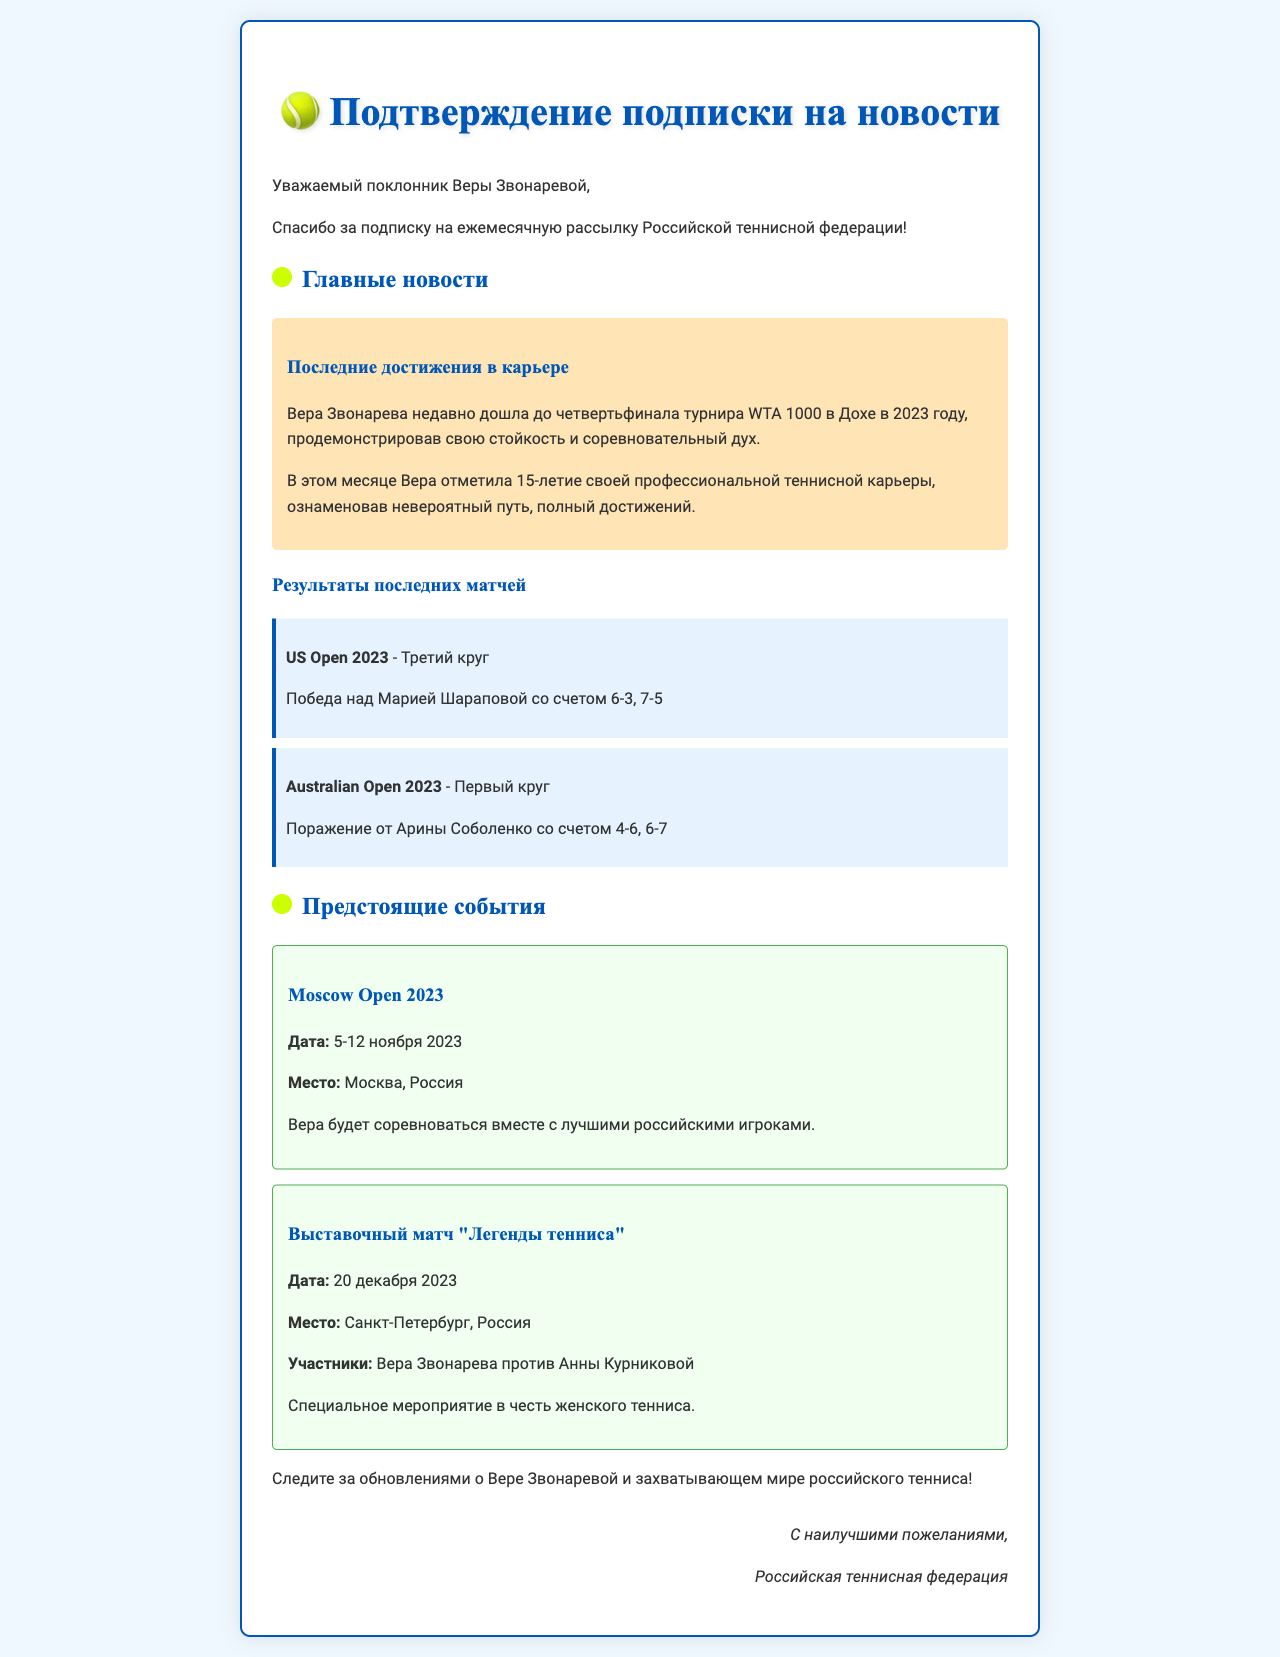what is the latest tournament achievement of Vera Zvonareva? Vera Zvonareva recently reached the quarter-finals of the WTA 1000 tournament in Doha in 2023.
Answer: quarter-finals of the WTA 1000 tournament in Doha what significant milestone did Vera Zvonareva celebrate this month? Vera marked the 15th anniversary of her professional tennis career, highlighting an incredible journey.
Answer: 15-летие своей профессиональной карьеры who did Vera Zvonareva defeat in the third round of the US Open 2023? Vera Zvonareva won against Maria Sharapova with a score of 6-3, 7-5.
Answer: Мария Шарапова when is the Moscow Open 2023 scheduled to take place? The Moscow Open 2023 will occur from November 5 to November 12, 2023.
Answer: 5-12 ноября 2023 what special match is Vera Zvonareva participating in on December 20, 2023? Vera Zvonareva will compete in the exhibition match "Legends of Tennis" against Anna Kournikova.
Answer: Выставочный матч "Легенды тенниса" what is the location of the upcoming Moscow Open 2023? The event will be held in Moscow, Russia.
Answer: Москва, Россия how did Vera Zvonareva perform in her first round match at the Australian Open 2023? She lost to Aryna Sabalenka with a score of 4-6, 6-7.
Answer: Поражение от Арины Соболенко who sent the confirmation newsletter? The newsletter was sent by the Russian Tennis Federation.
Answer: Российская теннисная федерация 